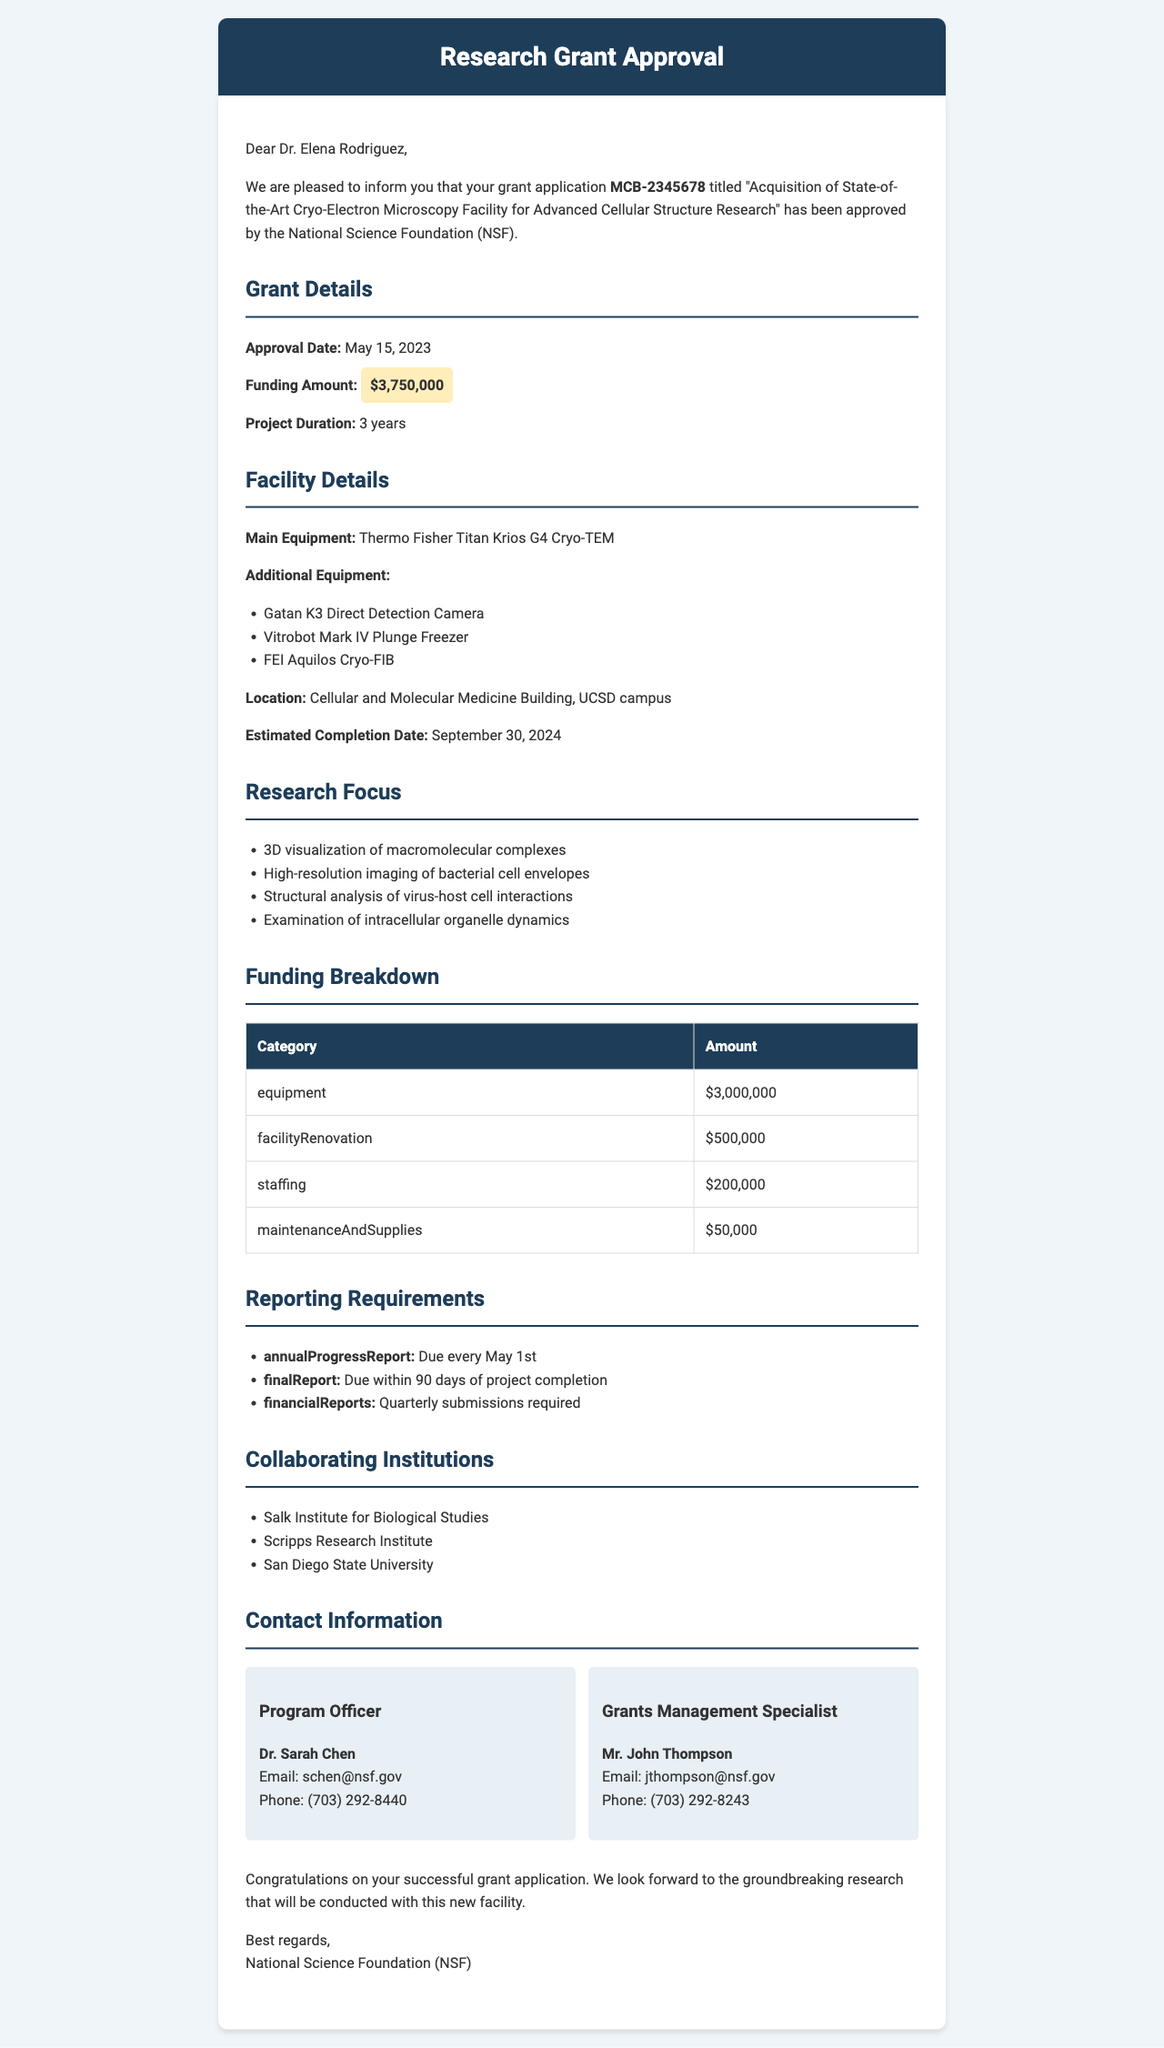What is the funding amount approved? The funding amount is explicitly stated in the grant approval letter as $3,750,000.
Answer: $3,750,000 When is the approval date of the grant? The date is specified in the letter, indicating when the grant was approved: May 15, 2023.
Answer: May 15, 2023 What is the estimated completion date of the facility? The document clearly mentions the estimated completion date for the facility as September 30, 2024.
Answer: September 30, 2024 Which equipment is the main focus of the facility? The letter lists the main equipment to be acquired, which is the Thermo Fisher Titan Krios G4 Cryo-TEM.
Answer: Thermo Fisher Titan Krios G4 Cryo-TEM How long is the project duration? The project duration is provided in the letter as 3 years.
Answer: 3 years What is the total funding allocated for equipment? The breakdown shows that the equipment funding is stated as $3,000,000.
Answer: $3,000,000 Name one of the collaborating institutions mentioned. The document lists several institutions, one of which is the Salk Institute for Biological Studies.
Answer: Salk Institute for Biological Studies What is the requirement for the annual progress report? The document explicitly states that the annual progress report is due every May 1st.
Answer: Due every May 1st Who is the program officer for this grant? The letter contains the name of the program officer, Dr. Sarah Chen, who is the contact person for the grant.
Answer: Dr. Sarah Chen 